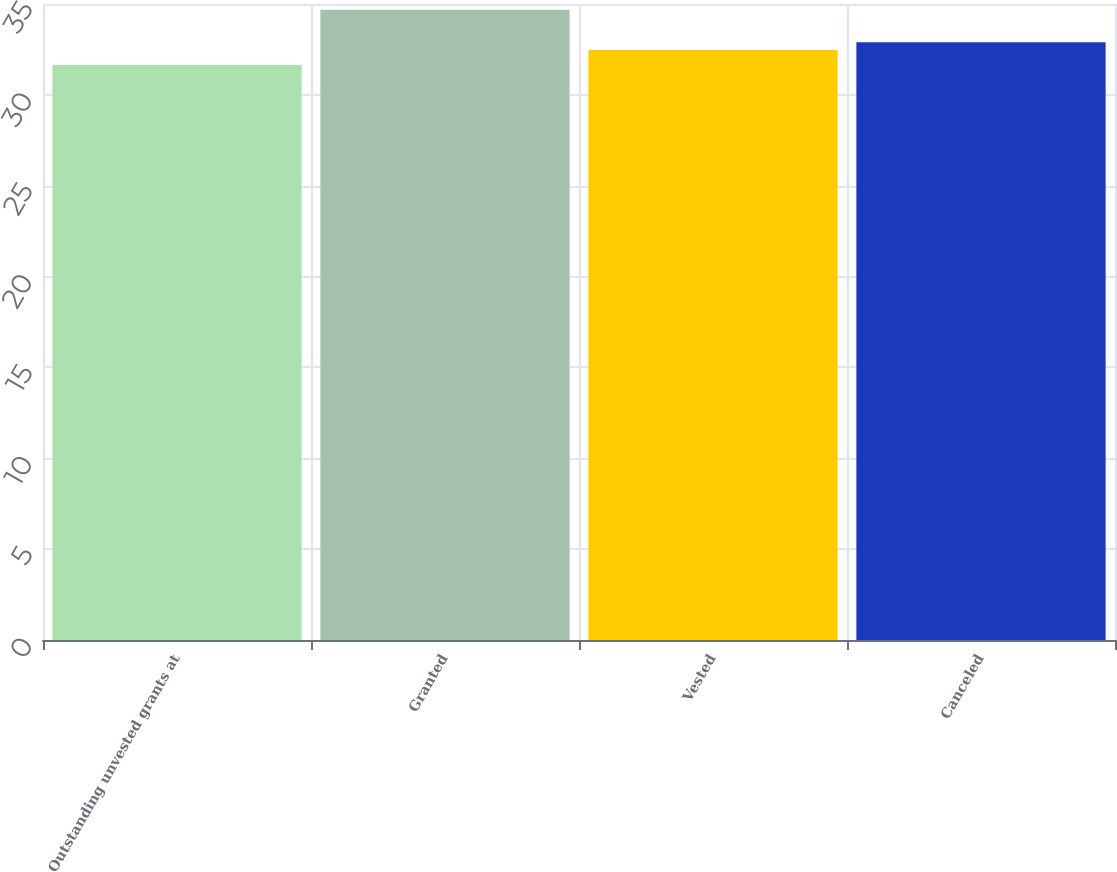Convert chart to OTSL. <chart><loc_0><loc_0><loc_500><loc_500><bar_chart><fcel>Outstanding unvested grants at<fcel>Granted<fcel>Vested<fcel>Canceled<nl><fcel>31.64<fcel>34.69<fcel>32.47<fcel>32.9<nl></chart> 